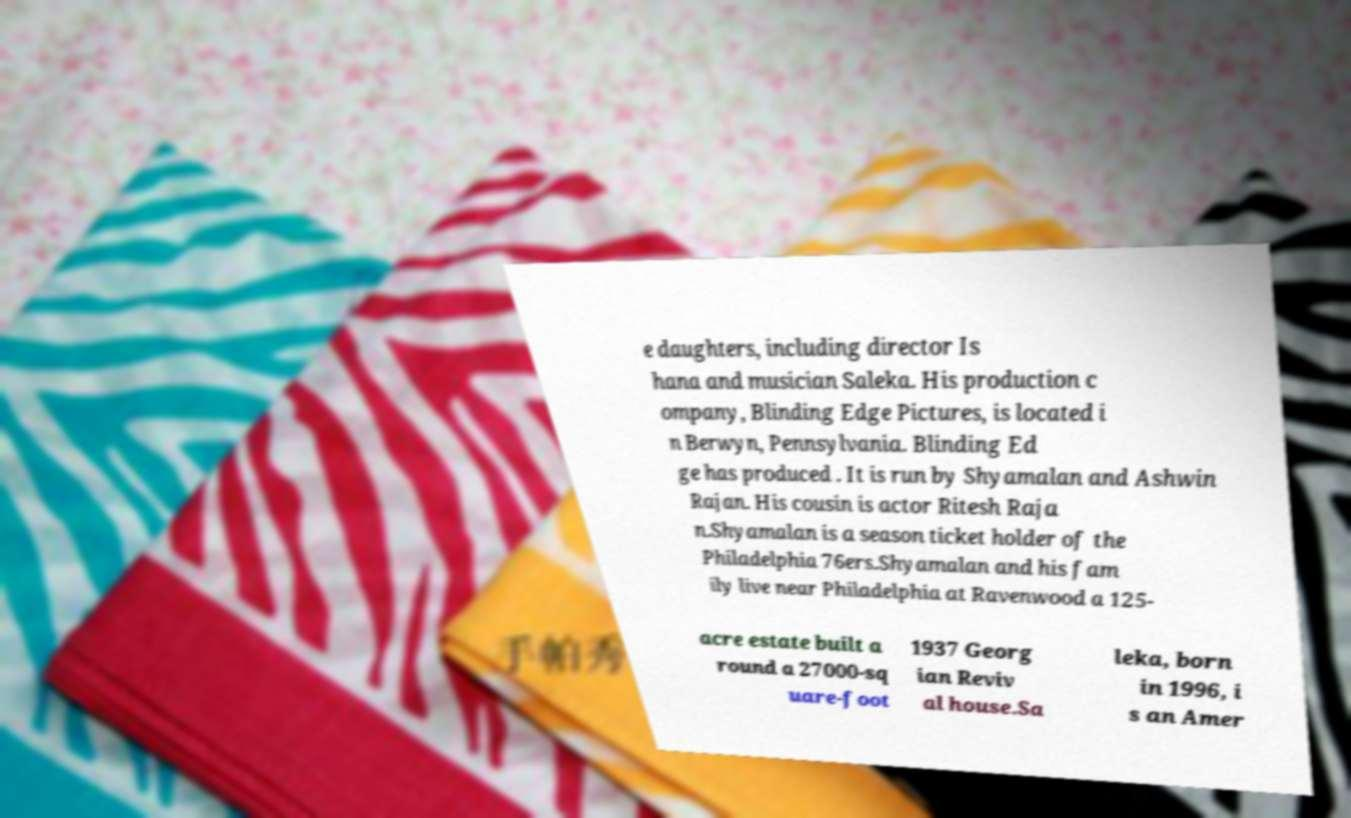Please read and relay the text visible in this image. What does it say? e daughters, including director Is hana and musician Saleka. His production c ompany, Blinding Edge Pictures, is located i n Berwyn, Pennsylvania. Blinding Ed ge has produced . It is run by Shyamalan and Ashwin Rajan. His cousin is actor Ritesh Raja n.Shyamalan is a season ticket holder of the Philadelphia 76ers.Shyamalan and his fam ily live near Philadelphia at Ravenwood a 125- acre estate built a round a 27000-sq uare-foot 1937 Georg ian Reviv al house.Sa leka, born in 1996, i s an Amer 